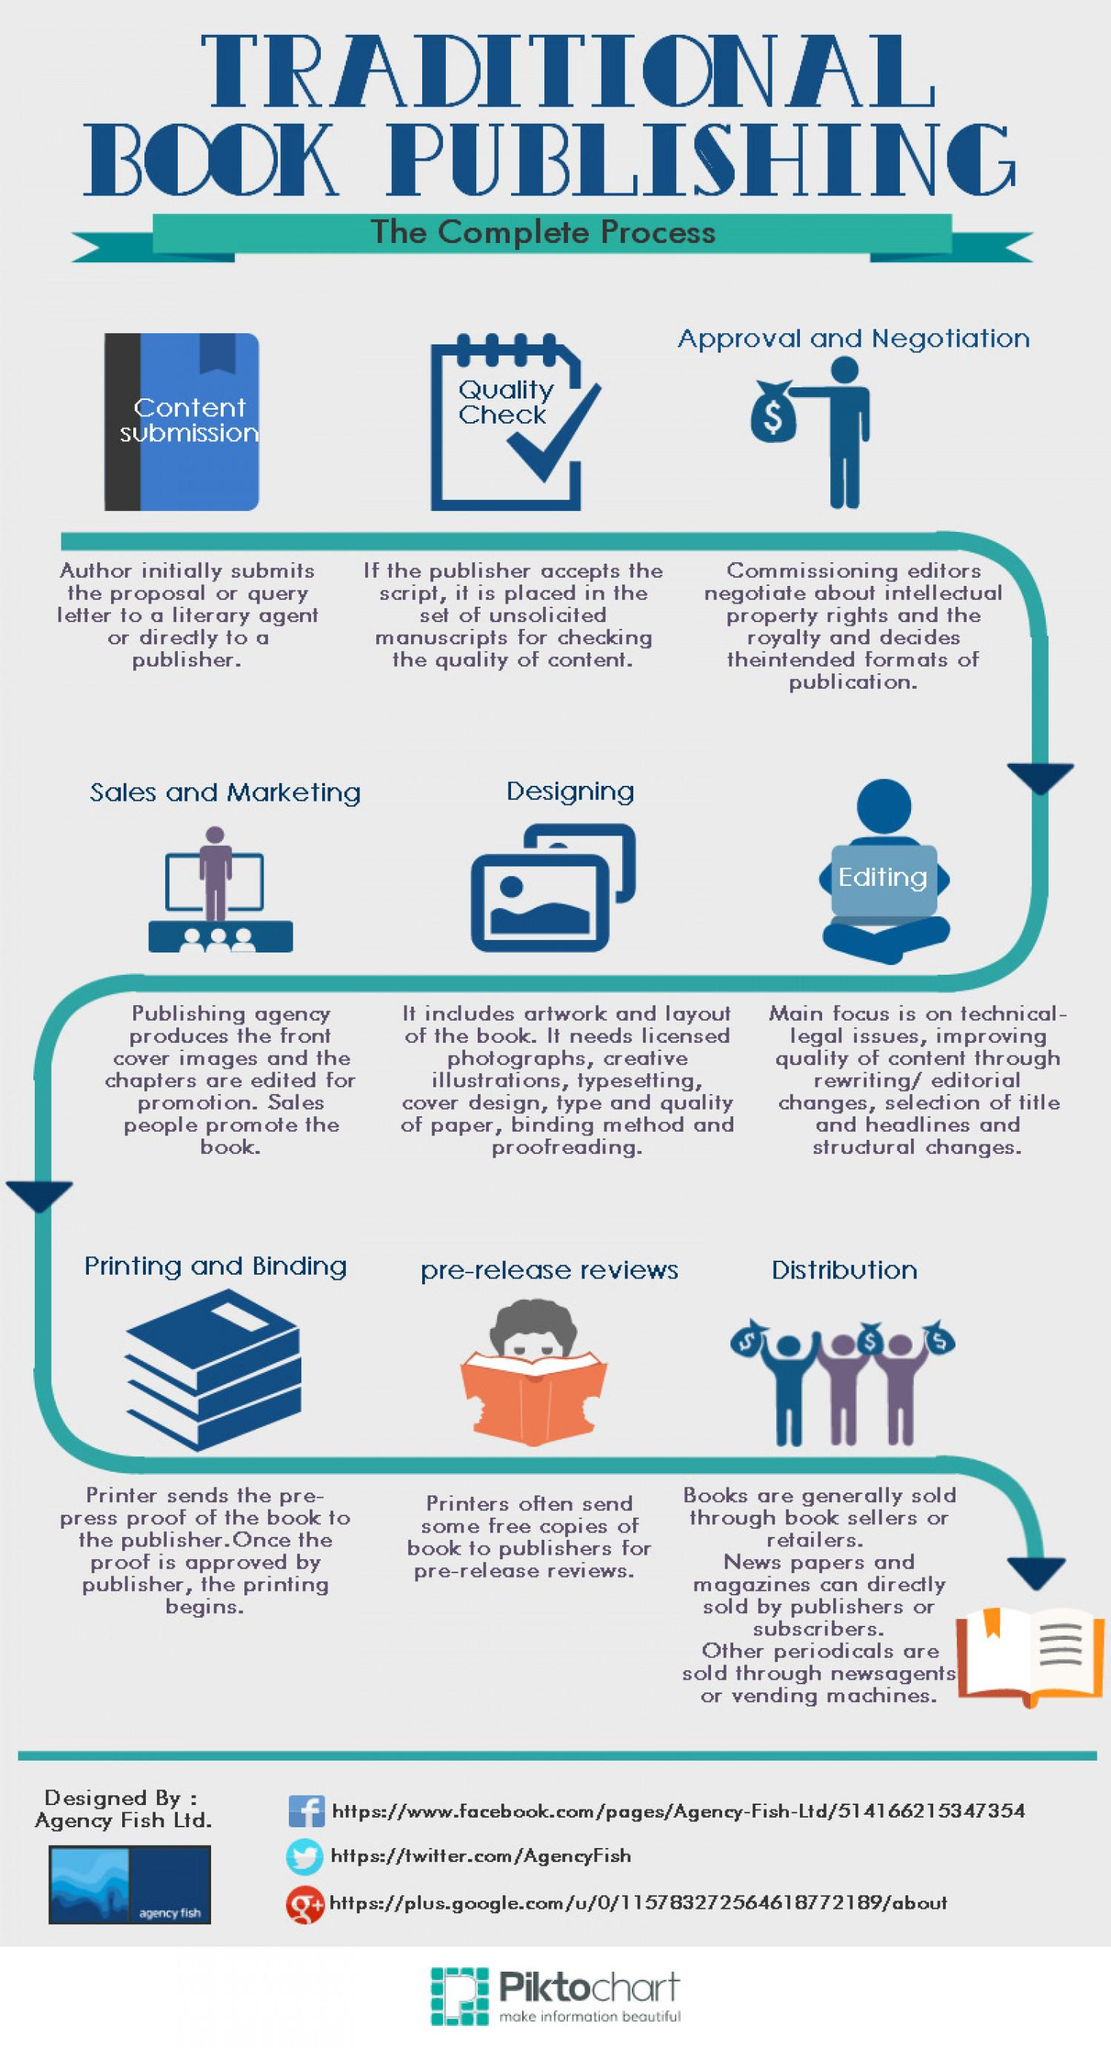Give some essential details in this illustration. There are 3 books that are currently in the process of printing and binding. The Twitter handle name "AgencyFish" was given. The book being held by the boy in pre-release reviews is orange in color. 